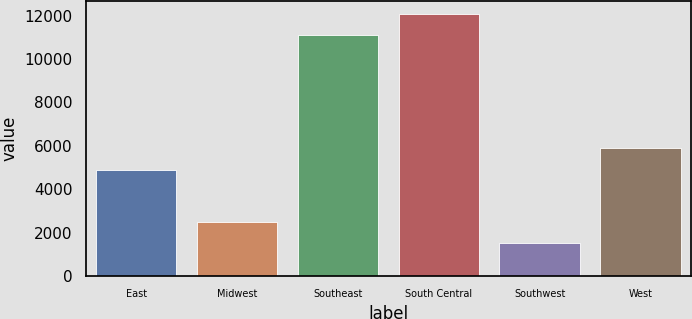Convert chart to OTSL. <chart><loc_0><loc_0><loc_500><loc_500><bar_chart><fcel>East<fcel>Midwest<fcel>Southeast<fcel>South Central<fcel>Southwest<fcel>West<nl><fcel>4880<fcel>2494.6<fcel>11093<fcel>12088.6<fcel>1499<fcel>5910<nl></chart> 